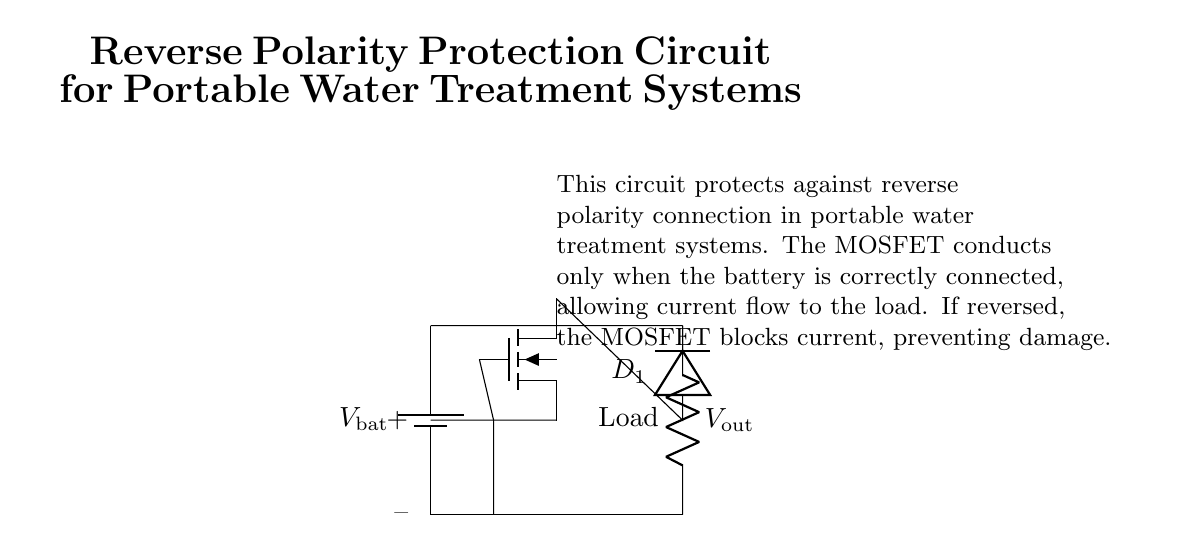What component is responsible for blocking current in reverse polarity? The MOSFET is responsible for blocking current when the polarity is reversed. In the circuit, if the battery is connected with reversed polarity, the MOSFET does not conduct, thus preventing current flow to the load.
Answer: MOSFET What does the symbol "D1" represent in this circuit? The symbol "D1" represents a diode in the circuit. It allows current to flow in one direction while blocking it in the opposite direction, providing essential protection against reverse polarity.
Answer: Diode What is the output voltage labeled as in the circuit? The output voltage is labeled as "Vout" in the circuit, representing the voltage available to the load after passing through the MOSFET and diode.
Answer: Vout How many components are used to form the protection circuit? There are three main components in the protection circuit: a battery, a MOSFET, and a diode. These components work together to ensure the circuit is protected from reverse polarity connections.
Answer: Three What happens to the load if the battery is connected with reverse polarity? If the battery is connected with reverse polarity, the MOSFET will block current flow, preventing damage to the load. Therefore, the load will not receive any voltage or current in such a scenario.
Answer: No current What is the role of the battery in this circuit? The role of the battery is to provide the necessary voltage and current to the circuit. It serves as the power source that drives the operation of the load when correctly connected.
Answer: Power source How does the MOSFET enable current flow when the battery is connected correctly? The MOSFET allows current flow when the battery is connected correctly by being in the "on" state. This state is achieved when the gate is positively biased by the battery, allowing current to flow from the source to the drain, and subsequently to the load.
Answer: Conducts current 